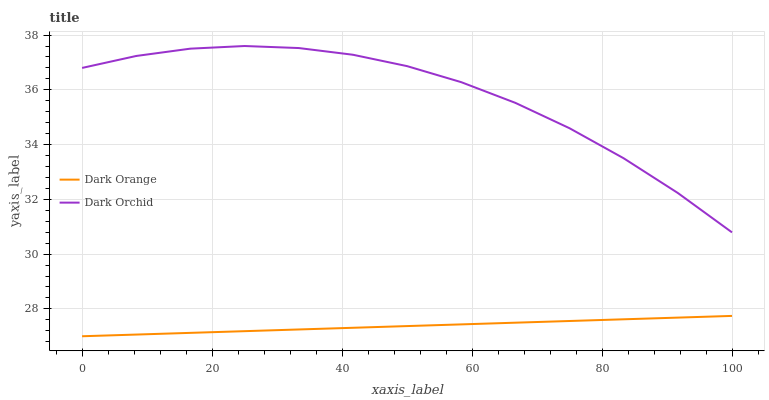Does Dark Orchid have the minimum area under the curve?
Answer yes or no. No. Is Dark Orchid the smoothest?
Answer yes or no. No. Does Dark Orchid have the lowest value?
Answer yes or no. No. Is Dark Orange less than Dark Orchid?
Answer yes or no. Yes. Is Dark Orchid greater than Dark Orange?
Answer yes or no. Yes. Does Dark Orange intersect Dark Orchid?
Answer yes or no. No. 